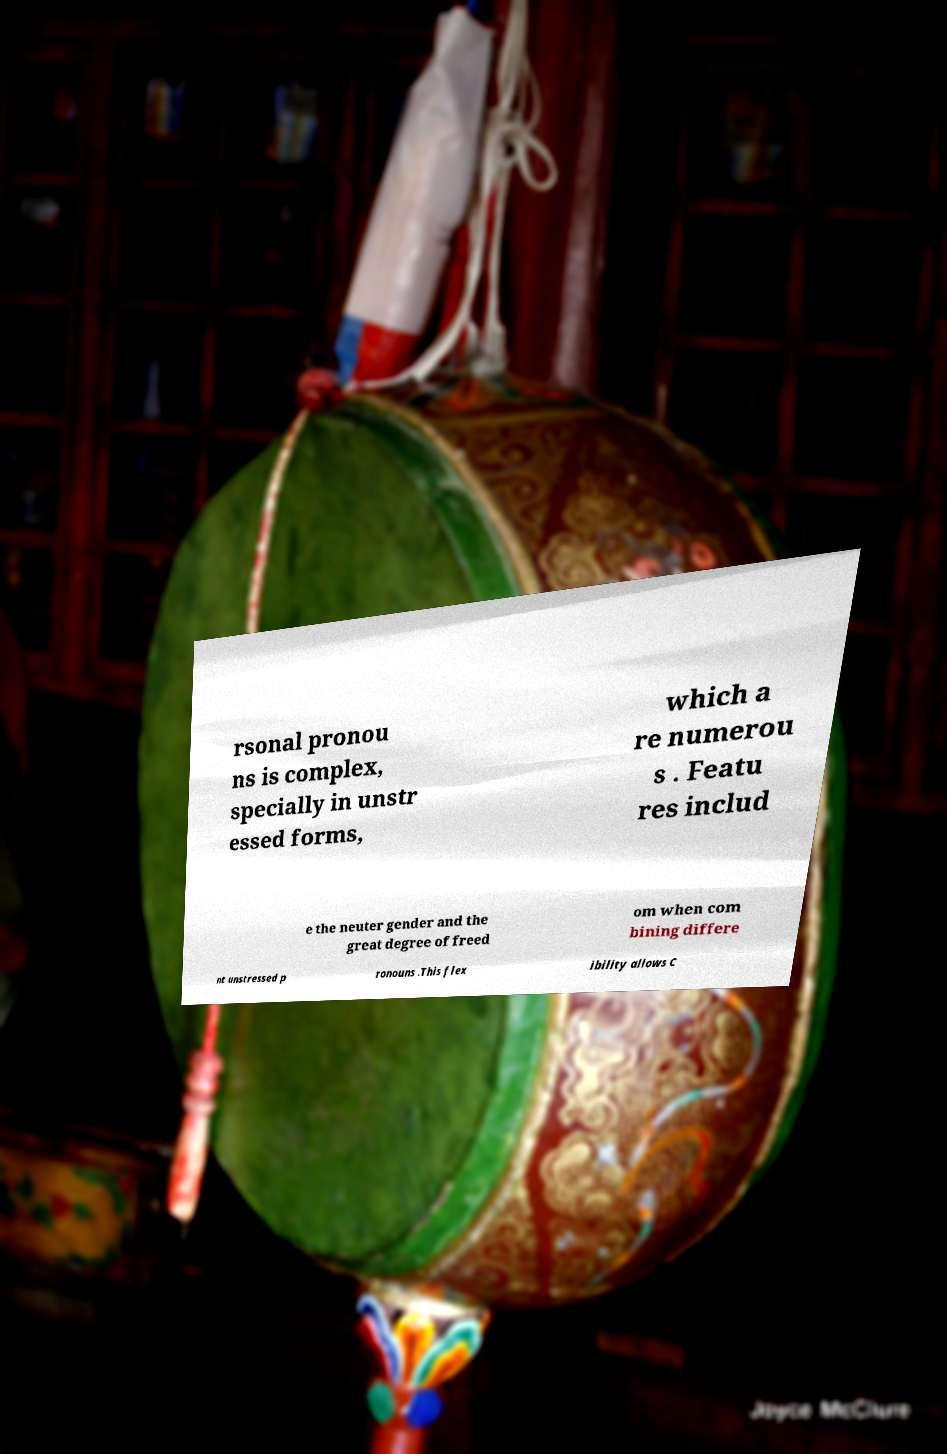Please read and relay the text visible in this image. What does it say? rsonal pronou ns is complex, specially in unstr essed forms, which a re numerou s . Featu res includ e the neuter gender and the great degree of freed om when com bining differe nt unstressed p ronouns .This flex ibility allows C 